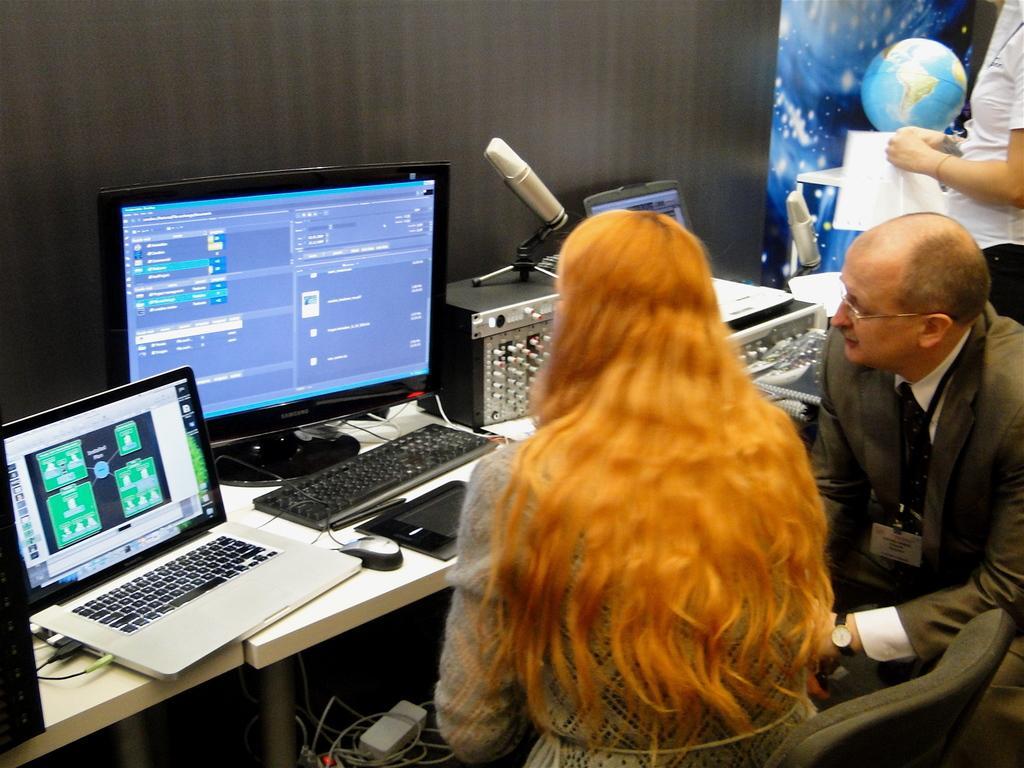Could you give a brief overview of what you see in this image? At the bottom of the image two persons are sitting. Behind them there is a table, on the table there are some laptop, screen, keyboards, mouse and there are some electronic devices. Behind the table there is wall. In the top right corner of the image a woman is standing and holding a paper. 